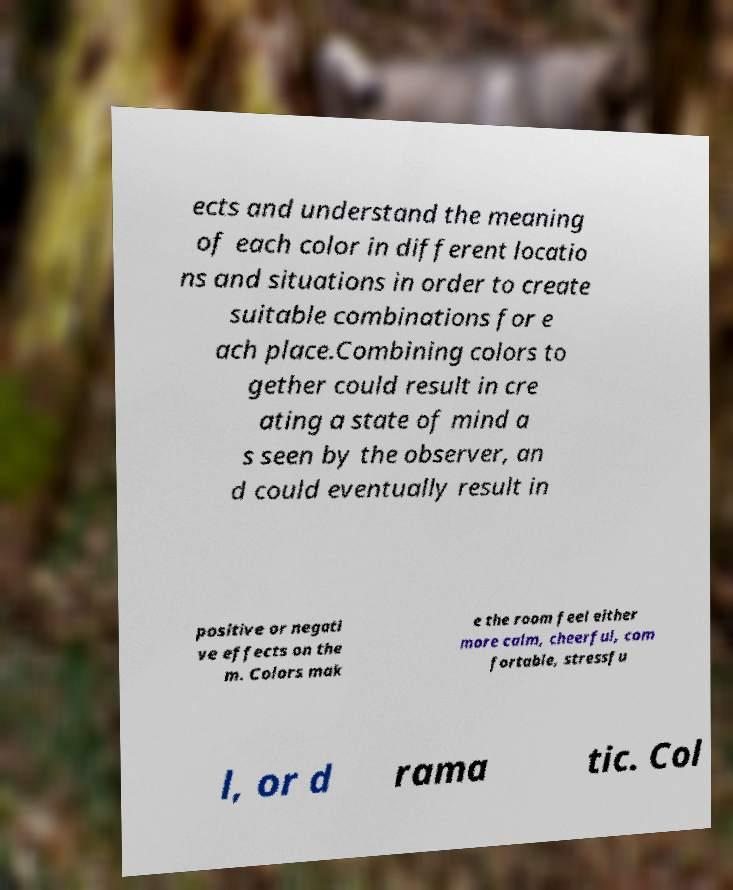Please identify and transcribe the text found in this image. ects and understand the meaning of each color in different locatio ns and situations in order to create suitable combinations for e ach place.Combining colors to gether could result in cre ating a state of mind a s seen by the observer, an d could eventually result in positive or negati ve effects on the m. Colors mak e the room feel either more calm, cheerful, com fortable, stressfu l, or d rama tic. Col 